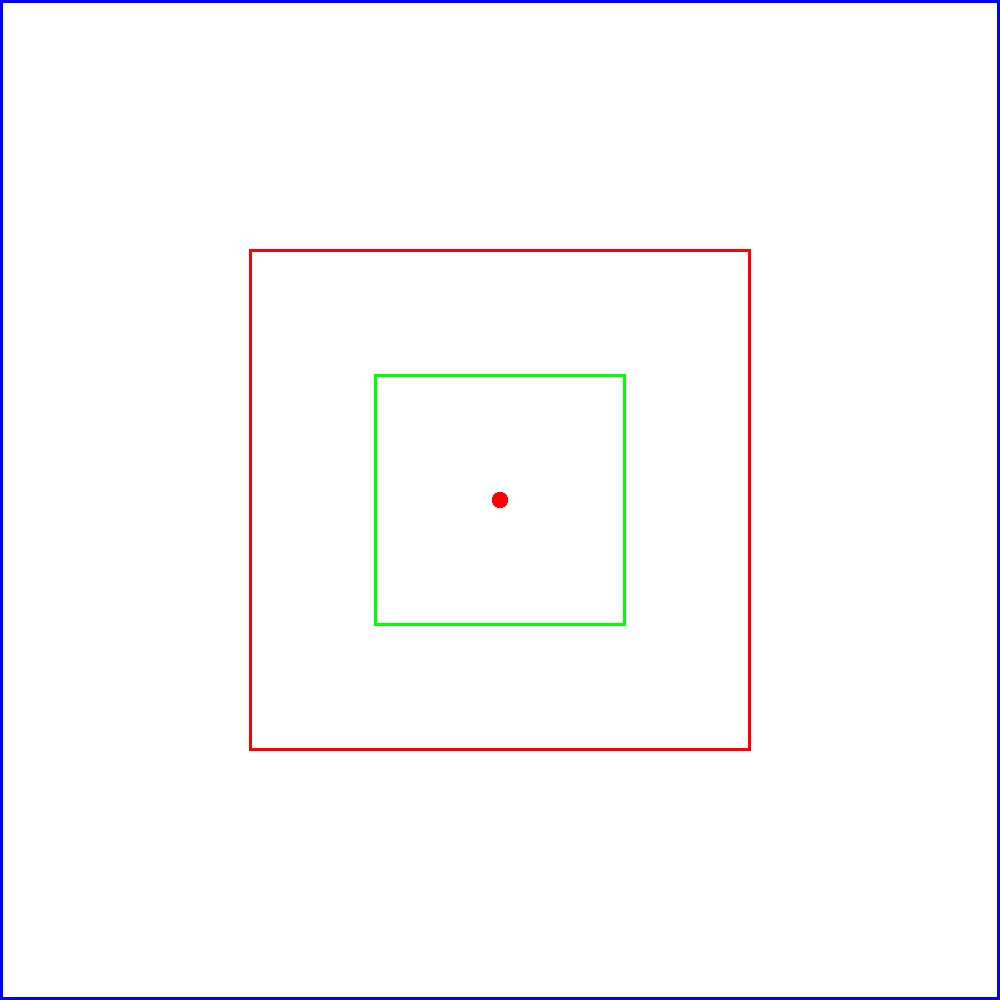In a traditional Norwegian textile design, a square pattern is composed of three nested squares as shown in the diagram. The outermost square has a side length of 2 units, the middle square has a side length of 1 unit, and the innermost square has a side length of 0.5 units. Calculate the number of lines of symmetry in this pattern. To determine the number of lines of symmetry in this pattern, we need to consider the following steps:

1. Identify the types of symmetry present:
   - Rotational symmetry
   - Reflection symmetry

2. Analyze rotational symmetry:
   - The pattern has 90-degree rotational symmetry (4-fold symmetry)
   - This means it looks the same when rotated 90°, 180°, 270°, and 360°

3. Analyze reflection symmetry:
   - Vertical line of symmetry through the center
   - Horizontal line of symmetry through the center
   - Two diagonal lines of symmetry (from corner to corner)

4. Count the lines of symmetry:
   - 1 vertical line
   - 1 horizontal line
   - 2 diagonal lines

5. Sum up the total number of lines of symmetry:
   $1 + 1 + 2 = 4$

Therefore, the pattern has 4 lines of symmetry.
Answer: 4 lines of symmetry 